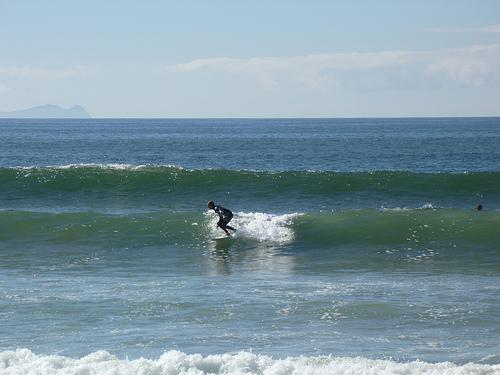Question: what is the person doing?
Choices:
A. Dancing.
B. Surfing.
C. Runnung.
D. Jogging.
Answer with the letter. Answer: B Question: where is he surfing?
Choices:
A. In the water.
B. At the beach.
C. In the sea.
D. Under the boardwalk.
Answer with the letter. Answer: A Question: what is he wearing?
Choices:
A. Shorts.
B. A wetsuit.
C. Knickers.
D. Boxers.
Answer with the letter. Answer: B Question: what is he standing on?
Choices:
A. Next to Teacher.
B. Next to boss.
C. A surfboard.
D. Next to Owner.
Answer with the letter. Answer: C 